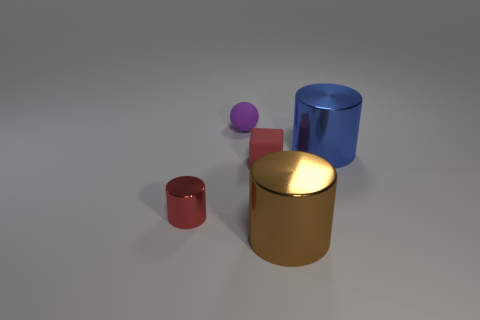Subtract all big blue cylinders. How many cylinders are left? 2 Subtract all cylinders. How many objects are left? 2 Add 2 small shiny balls. How many objects exist? 7 Subtract 0 green blocks. How many objects are left? 5 Subtract 1 blocks. How many blocks are left? 0 Subtract all cyan cylinders. Subtract all green cubes. How many cylinders are left? 3 Subtract all yellow spheres. How many blue cylinders are left? 1 Subtract all small purple cylinders. Subtract all small purple matte balls. How many objects are left? 4 Add 3 tiny red things. How many tiny red things are left? 5 Add 3 large brown objects. How many large brown objects exist? 4 